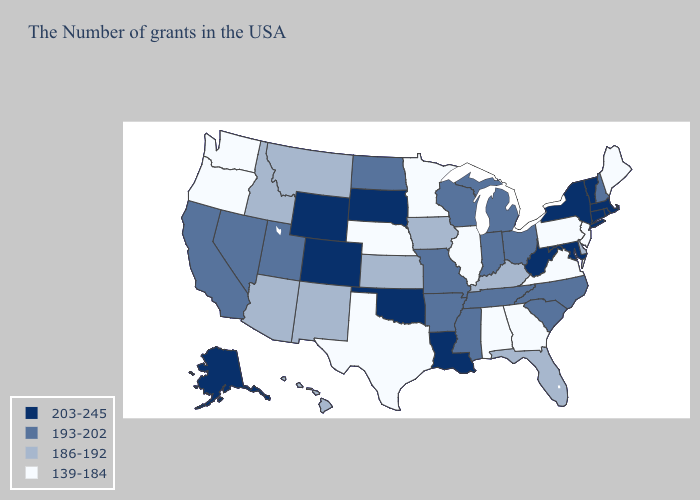What is the value of New York?
Short answer required. 203-245. Name the states that have a value in the range 203-245?
Short answer required. Massachusetts, Rhode Island, Vermont, Connecticut, New York, Maryland, West Virginia, Louisiana, Oklahoma, South Dakota, Wyoming, Colorado, Alaska. Among the states that border Georgia , which have the highest value?
Be succinct. North Carolina, South Carolina, Tennessee. Which states have the lowest value in the West?
Short answer required. Washington, Oregon. What is the value of New Mexico?
Quick response, please. 186-192. What is the value of Arizona?
Answer briefly. 186-192. What is the value of West Virginia?
Answer briefly. 203-245. Does the first symbol in the legend represent the smallest category?
Answer briefly. No. What is the lowest value in the Northeast?
Answer briefly. 139-184. What is the value of Iowa?
Be succinct. 186-192. Does Maine have a lower value than Pennsylvania?
Quick response, please. No. What is the lowest value in states that border South Carolina?
Concise answer only. 139-184. What is the lowest value in states that border Minnesota?
Quick response, please. 186-192. Does Georgia have the lowest value in the South?
Keep it brief. Yes. What is the lowest value in the USA?
Concise answer only. 139-184. 